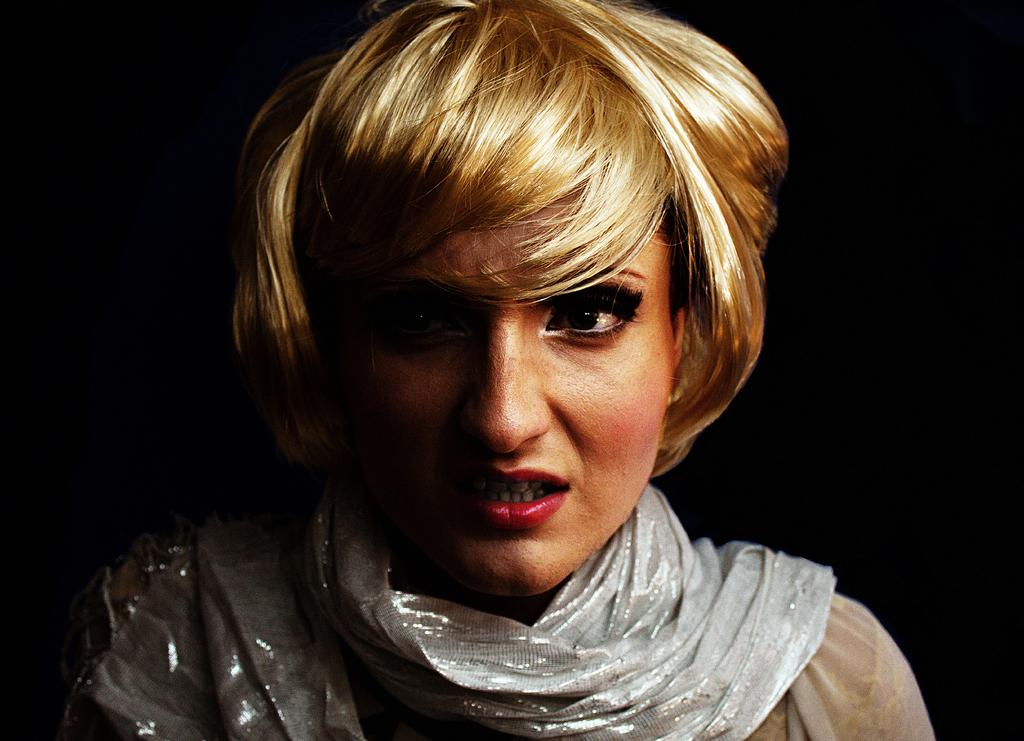Who is present in the image? There is a woman in the image. What is the woman wearing around her neck? The woman is wearing a white scarf. What can be observed about the background of the image? The background of the image is dark. Can you see any ocean waves in the image? There is no ocean or waves present in the image. What type of pot is being used by the woman in the image? There is no pot visible in the image, as it only features a woman wearing a white scarf with a dark background. 